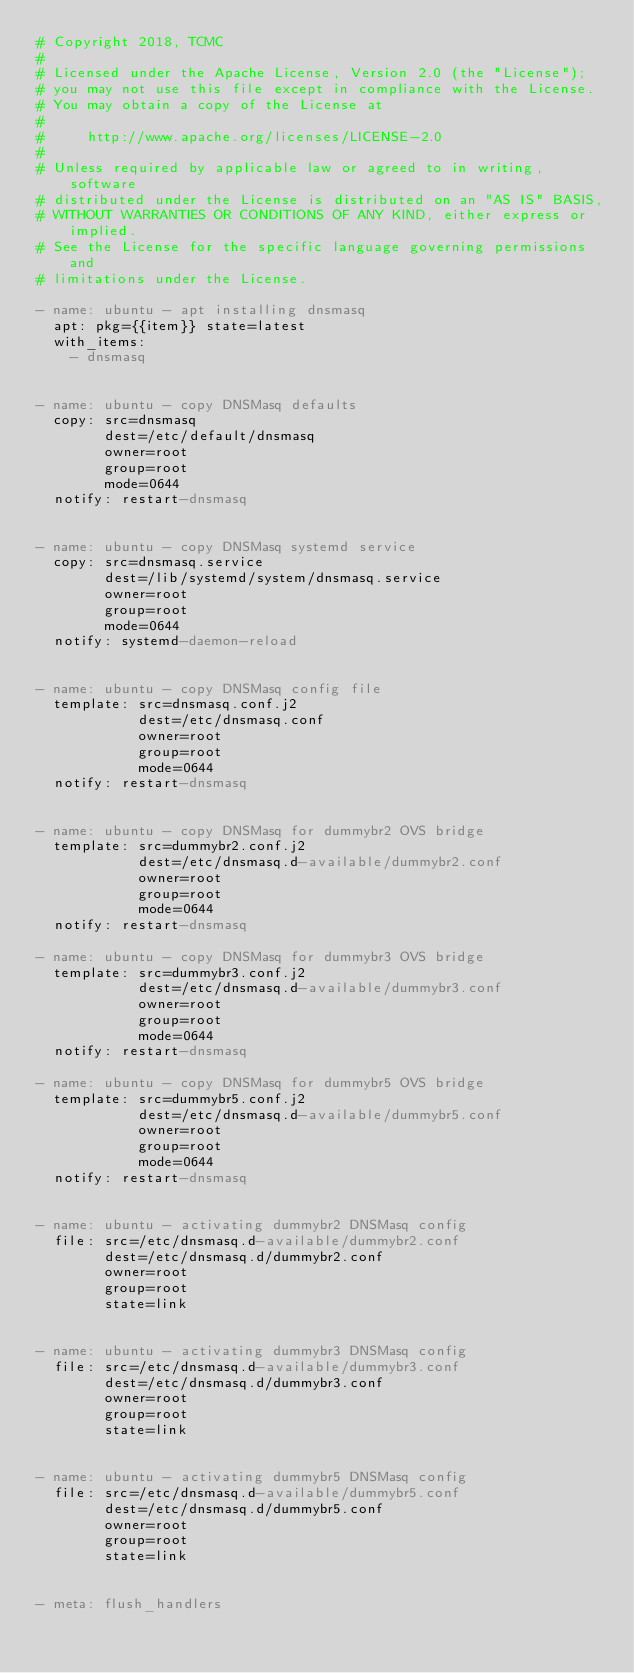<code> <loc_0><loc_0><loc_500><loc_500><_YAML_># Copyright 2018, TCMC
#
# Licensed under the Apache License, Version 2.0 (the "License");
# you may not use this file except in compliance with the License.
# You may obtain a copy of the License at
#
#     http://www.apache.org/licenses/LICENSE-2.0
#
# Unless required by applicable law or agreed to in writing, software
# distributed under the License is distributed on an "AS IS" BASIS,
# WITHOUT WARRANTIES OR CONDITIONS OF ANY KIND, either express or implied.
# See the License for the specific language governing permissions and
# limitations under the License.

- name: ubuntu - apt installing dnsmasq
  apt: pkg={{item}} state=latest
  with_items:
    - dnsmasq


- name: ubuntu - copy DNSMasq defaults
  copy: src=dnsmasq
        dest=/etc/default/dnsmasq
        owner=root
        group=root
        mode=0644
  notify: restart-dnsmasq


- name: ubuntu - copy DNSMasq systemd service
  copy: src=dnsmasq.service
        dest=/lib/systemd/system/dnsmasq.service
        owner=root
        group=root
        mode=0644
  notify: systemd-daemon-reload


- name: ubuntu - copy DNSMasq config file
  template: src=dnsmasq.conf.j2
            dest=/etc/dnsmasq.conf
            owner=root
            group=root
            mode=0644
  notify: restart-dnsmasq


- name: ubuntu - copy DNSMasq for dummybr2 OVS bridge
  template: src=dummybr2.conf.j2
            dest=/etc/dnsmasq.d-available/dummybr2.conf
            owner=root
            group=root
            mode=0644
  notify: restart-dnsmasq

- name: ubuntu - copy DNSMasq for dummybr3 OVS bridge
  template: src=dummybr3.conf.j2
            dest=/etc/dnsmasq.d-available/dummybr3.conf
            owner=root
            group=root
            mode=0644
  notify: restart-dnsmasq

- name: ubuntu - copy DNSMasq for dummybr5 OVS bridge
  template: src=dummybr5.conf.j2
            dest=/etc/dnsmasq.d-available/dummybr5.conf
            owner=root
            group=root
            mode=0644
  notify: restart-dnsmasq


- name: ubuntu - activating dummybr2 DNSMasq config
  file: src=/etc/dnsmasq.d-available/dummybr2.conf
        dest=/etc/dnsmasq.d/dummybr2.conf
        owner=root
        group=root
        state=link


- name: ubuntu - activating dummybr3 DNSMasq config
  file: src=/etc/dnsmasq.d-available/dummybr3.conf
        dest=/etc/dnsmasq.d/dummybr3.conf
        owner=root
        group=root
        state=link


- name: ubuntu - activating dummybr5 DNSMasq config
  file: src=/etc/dnsmasq.d-available/dummybr5.conf
        dest=/etc/dnsmasq.d/dummybr5.conf
        owner=root
        group=root
        state=link


- meta: flush_handlers
</code> 